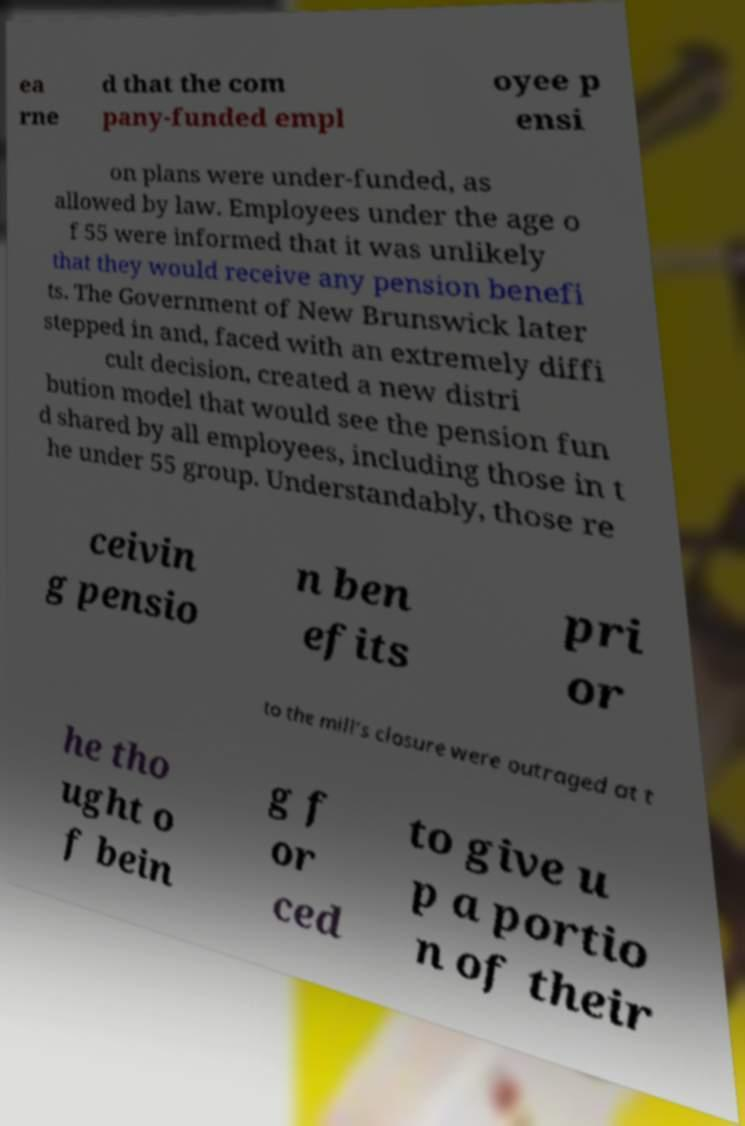Can you read and provide the text displayed in the image?This photo seems to have some interesting text. Can you extract and type it out for me? ea rne d that the com pany-funded empl oyee p ensi on plans were under-funded, as allowed by law. Employees under the age o f 55 were informed that it was unlikely that they would receive any pension benefi ts. The Government of New Brunswick later stepped in and, faced with an extremely diffi cult decision, created a new distri bution model that would see the pension fun d shared by all employees, including those in t he under 55 group. Understandably, those re ceivin g pensio n ben efits pri or to the mill’s closure were outraged at t he tho ught o f bein g f or ced to give u p a portio n of their 